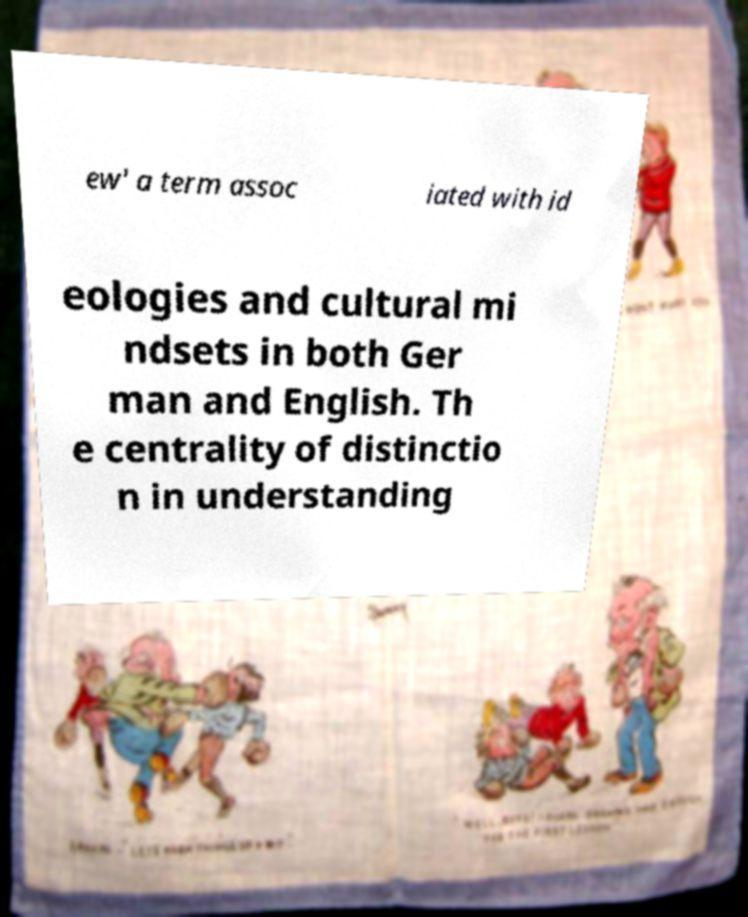Can you read and provide the text displayed in the image?This photo seems to have some interesting text. Can you extract and type it out for me? ew' a term assoc iated with id eologies and cultural mi ndsets in both Ger man and English. Th e centrality of distinctio n in understanding 